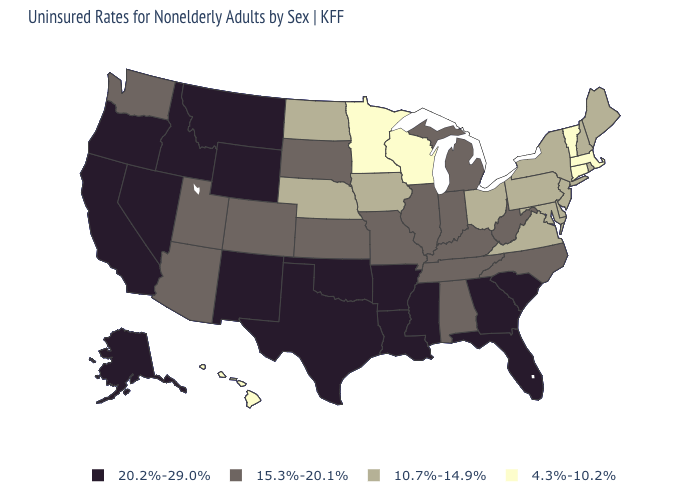Among the states that border South Carolina , does Georgia have the lowest value?
Answer briefly. No. Which states have the highest value in the USA?
Give a very brief answer. Alaska, Arkansas, California, Florida, Georgia, Idaho, Louisiana, Mississippi, Montana, Nevada, New Mexico, Oklahoma, Oregon, South Carolina, Texas, Wyoming. What is the value of Vermont?
Write a very short answer. 4.3%-10.2%. What is the highest value in the South ?
Give a very brief answer. 20.2%-29.0%. Name the states that have a value in the range 20.2%-29.0%?
Short answer required. Alaska, Arkansas, California, Florida, Georgia, Idaho, Louisiana, Mississippi, Montana, Nevada, New Mexico, Oklahoma, Oregon, South Carolina, Texas, Wyoming. Which states have the highest value in the USA?
Answer briefly. Alaska, Arkansas, California, Florida, Georgia, Idaho, Louisiana, Mississippi, Montana, Nevada, New Mexico, Oklahoma, Oregon, South Carolina, Texas, Wyoming. Does South Carolina have the highest value in the South?
Be succinct. Yes. Name the states that have a value in the range 15.3%-20.1%?
Short answer required. Alabama, Arizona, Colorado, Illinois, Indiana, Kansas, Kentucky, Michigan, Missouri, North Carolina, South Dakota, Tennessee, Utah, Washington, West Virginia. Among the states that border Arizona , does Colorado have the lowest value?
Give a very brief answer. Yes. Among the states that border Utah , does Colorado have the lowest value?
Quick response, please. Yes. Name the states that have a value in the range 20.2%-29.0%?
Give a very brief answer. Alaska, Arkansas, California, Florida, Georgia, Idaho, Louisiana, Mississippi, Montana, Nevada, New Mexico, Oklahoma, Oregon, South Carolina, Texas, Wyoming. What is the value of Washington?
Be succinct. 15.3%-20.1%. What is the value of Maine?
Short answer required. 10.7%-14.9%. Which states have the lowest value in the South?
Keep it brief. Delaware, Maryland, Virginia. What is the value of Utah?
Write a very short answer. 15.3%-20.1%. 